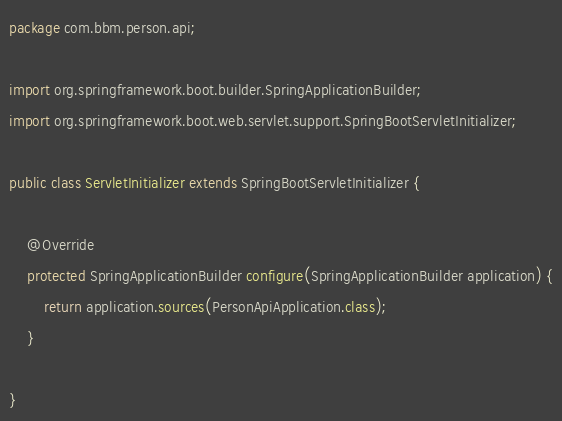<code> <loc_0><loc_0><loc_500><loc_500><_Java_>package com.bbm.person.api;

import org.springframework.boot.builder.SpringApplicationBuilder;
import org.springframework.boot.web.servlet.support.SpringBootServletInitializer;

public class ServletInitializer extends SpringBootServletInitializer {

	@Override
	protected SpringApplicationBuilder configure(SpringApplicationBuilder application) {
		return application.sources(PersonApiApplication.class);
	}

}
</code> 